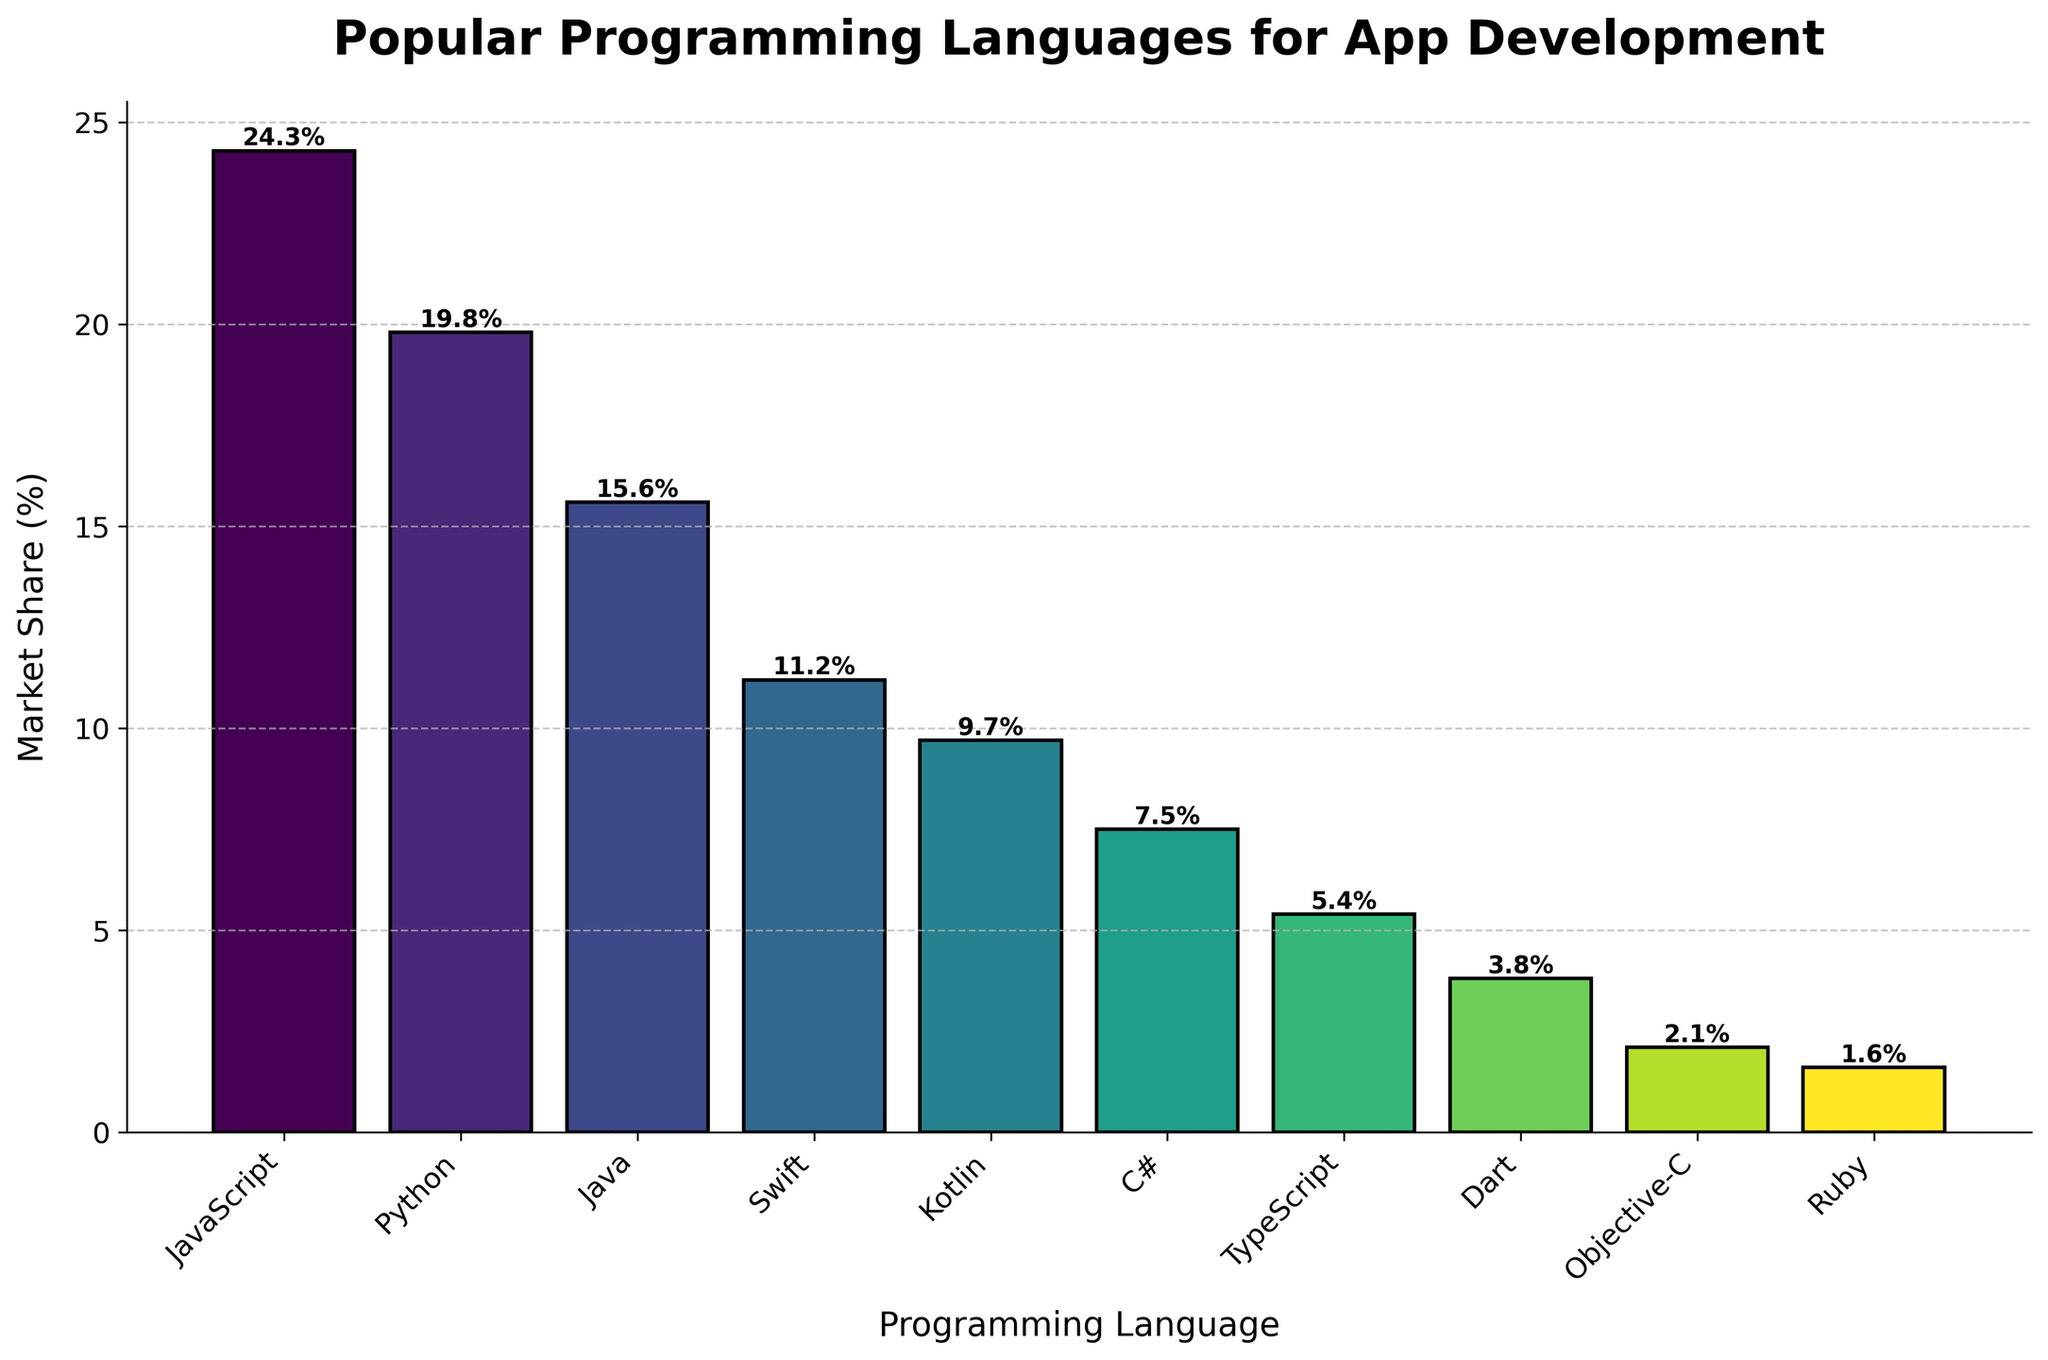What is the market share of JavaScript compared to Python? JavaScript has a market share of 24.3%, and Python has a market share of 19.8%. To compare, subtract Python's market share from JavaScript's: 24.3% - 19.8% = 4.5%.
Answer: 4.5% Which programming language has the lowest market share and what is that share? From the bar chart, Ruby has the lowest market share among the listed languages, which is 1.6%.
Answer: Ruby, 1.6% How many languages have a market share greater than 10%? By analyzing the bars, the languages with a market share greater than 10% are JavaScript, Python, Java, and Swift. Count those: 4 languages.
Answer: 4 What is the total market share of Kotlin, Swift, and Dart combined? Sum the individual market shares of Kotlin (9.7%), Swift (11.2%), and Dart (3.8%): 9.7% + 11.2% + 3.8% = 24.7%.
Answer: 24.7% Which language has a higher market share, C# or TypeScript, and by how much? From the chart, C# has a market share of 7.5% while TypeScript has 5.4%. Subtract TypeScript's share from C#'s: 7.5% - 5.4% = 2.1%.
Answer: C#, 2.1% Of the languages listed, which one has a market share closest to 10%? From the chart, Kotlin is the closest with a market share of 9.7%, which is near 10%.
Answer: Kotlin, 9.7% What is the average market share of Python, Java, and Swift? To calculate the average, sum the market shares of Python (19.8%), Java (15.6%), and Swift (11.2%), then divide by 3: (19.8% + 15.6% + 11.2%) / 3 = 15.53%.
Answer: 15.53% Compare the market share of Objective-C to Ruby. Which is greater and by how much? Objective-C has a market share of 2.1% and Ruby has 1.6%. Subtract Ruby's share from Objective-C's: 2.1% - 1.6% = 0.5%.
Answer: Objective-C, 0.5% Which programming language has the second-highest market share and what is that share? From the chart, after JavaScript, Python has the second-highest market share of 19.8%.
Answer: Python, 19.8% What is the combined market share of the three least popular languages? The three least popular languages are Ruby (1.6%), Objective-C (2.1%), and Dart (3.8%). Sum their shares: 1.6% + 2.1% + 3.8% = 7.5%.
Answer: 7.5% 